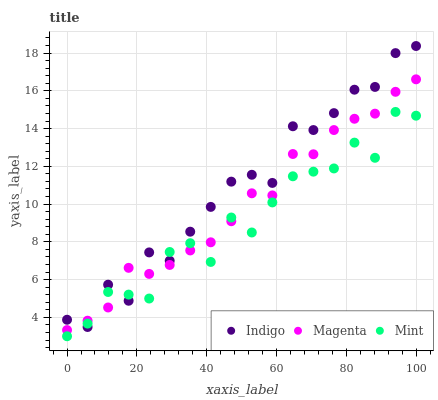Does Mint have the minimum area under the curve?
Answer yes or no. Yes. Does Indigo have the maximum area under the curve?
Answer yes or no. Yes. Does Magenta have the minimum area under the curve?
Answer yes or no. No. Does Magenta have the maximum area under the curve?
Answer yes or no. No. Is Magenta the smoothest?
Answer yes or no. Yes. Is Mint the roughest?
Answer yes or no. Yes. Is Indigo the smoothest?
Answer yes or no. No. Is Indigo the roughest?
Answer yes or no. No. Does Mint have the lowest value?
Answer yes or no. Yes. Does Magenta have the lowest value?
Answer yes or no. No. Does Indigo have the highest value?
Answer yes or no. Yes. Does Magenta have the highest value?
Answer yes or no. No. Does Mint intersect Indigo?
Answer yes or no. Yes. Is Mint less than Indigo?
Answer yes or no. No. Is Mint greater than Indigo?
Answer yes or no. No. 